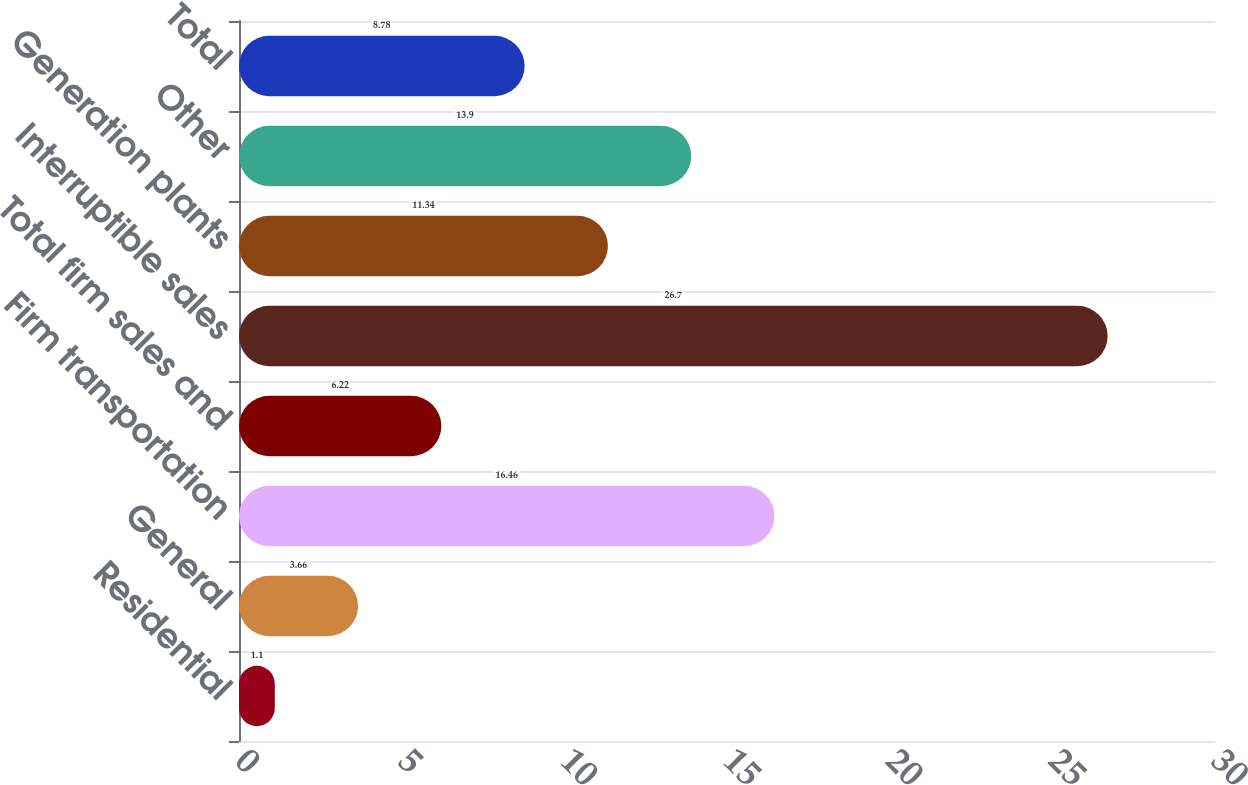Convert chart. <chart><loc_0><loc_0><loc_500><loc_500><bar_chart><fcel>Residential<fcel>General<fcel>Firm transportation<fcel>Total firm sales and<fcel>Interruptible sales<fcel>Generation plants<fcel>Other<fcel>Total<nl><fcel>1.1<fcel>3.66<fcel>16.46<fcel>6.22<fcel>26.7<fcel>11.34<fcel>13.9<fcel>8.78<nl></chart> 